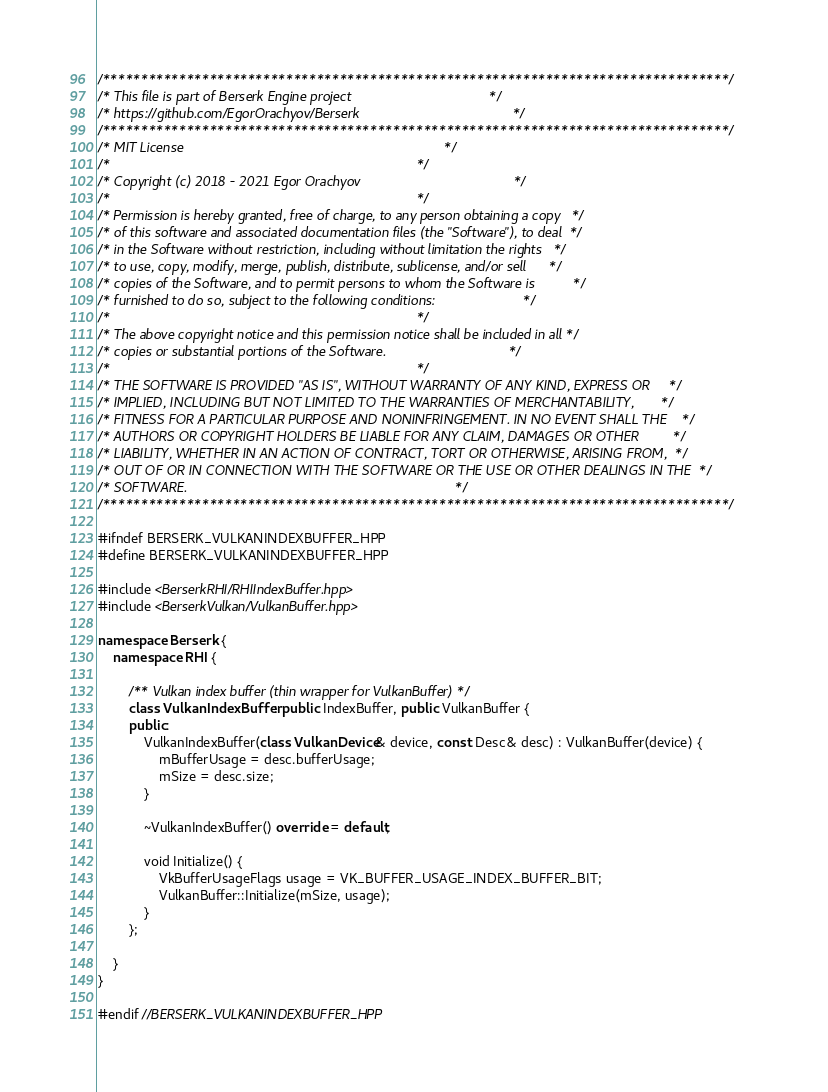<code> <loc_0><loc_0><loc_500><loc_500><_C++_>/**********************************************************************************/
/* This file is part of Berserk Engine project                                    */
/* https://github.com/EgorOrachyov/Berserk                                        */
/**********************************************************************************/
/* MIT License                                                                    */
/*                                                                                */
/* Copyright (c) 2018 - 2021 Egor Orachyov                                        */
/*                                                                                */
/* Permission is hereby granted, free of charge, to any person obtaining a copy   */
/* of this software and associated documentation files (the "Software"), to deal  */
/* in the Software without restriction, including without limitation the rights   */
/* to use, copy, modify, merge, publish, distribute, sublicense, and/or sell      */
/* copies of the Software, and to permit persons to whom the Software is          */
/* furnished to do so, subject to the following conditions:                       */
/*                                                                                */
/* The above copyright notice and this permission notice shall be included in all */
/* copies or substantial portions of the Software.                                */
/*                                                                                */
/* THE SOFTWARE IS PROVIDED "AS IS", WITHOUT WARRANTY OF ANY KIND, EXPRESS OR     */
/* IMPLIED, INCLUDING BUT NOT LIMITED TO THE WARRANTIES OF MERCHANTABILITY,       */
/* FITNESS FOR A PARTICULAR PURPOSE AND NONINFRINGEMENT. IN NO EVENT SHALL THE    */
/* AUTHORS OR COPYRIGHT HOLDERS BE LIABLE FOR ANY CLAIM, DAMAGES OR OTHER         */
/* LIABILITY, WHETHER IN AN ACTION OF CONTRACT, TORT OR OTHERWISE, ARISING FROM,  */
/* OUT OF OR IN CONNECTION WITH THE SOFTWARE OR THE USE OR OTHER DEALINGS IN THE  */
/* SOFTWARE.                                                                      */
/**********************************************************************************/

#ifndef BERSERK_VULKANINDEXBUFFER_HPP
#define BERSERK_VULKANINDEXBUFFER_HPP

#include <BerserkRHI/RHIIndexBuffer.hpp>
#include <BerserkVulkan/VulkanBuffer.hpp>

namespace Berserk {
    namespace RHI {

        /** Vulkan index buffer (thin wrapper for VulkanBuffer) */
        class VulkanIndexBuffer: public IndexBuffer, public VulkanBuffer {
        public:
            VulkanIndexBuffer(class VulkanDevice& device, const Desc& desc) : VulkanBuffer(device) {
                mBufferUsage = desc.bufferUsage;
                mSize = desc.size;
            }

            ~VulkanIndexBuffer() override = default;

            void Initialize() {
                VkBufferUsageFlags usage = VK_BUFFER_USAGE_INDEX_BUFFER_BIT;
                VulkanBuffer::Initialize(mSize, usage);
            }
        };

    }
}

#endif //BERSERK_VULKANINDEXBUFFER_HPP
</code> 